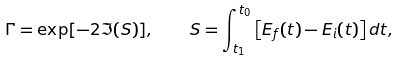<formula> <loc_0><loc_0><loc_500><loc_500>\Gamma = \exp [ - 2 \Im ( S ) ] , \quad S = \int _ { t _ { 1 } } ^ { t _ { 0 } } \left [ E _ { f } ( t ) - E _ { i } ( t ) \right ] d t ,</formula> 